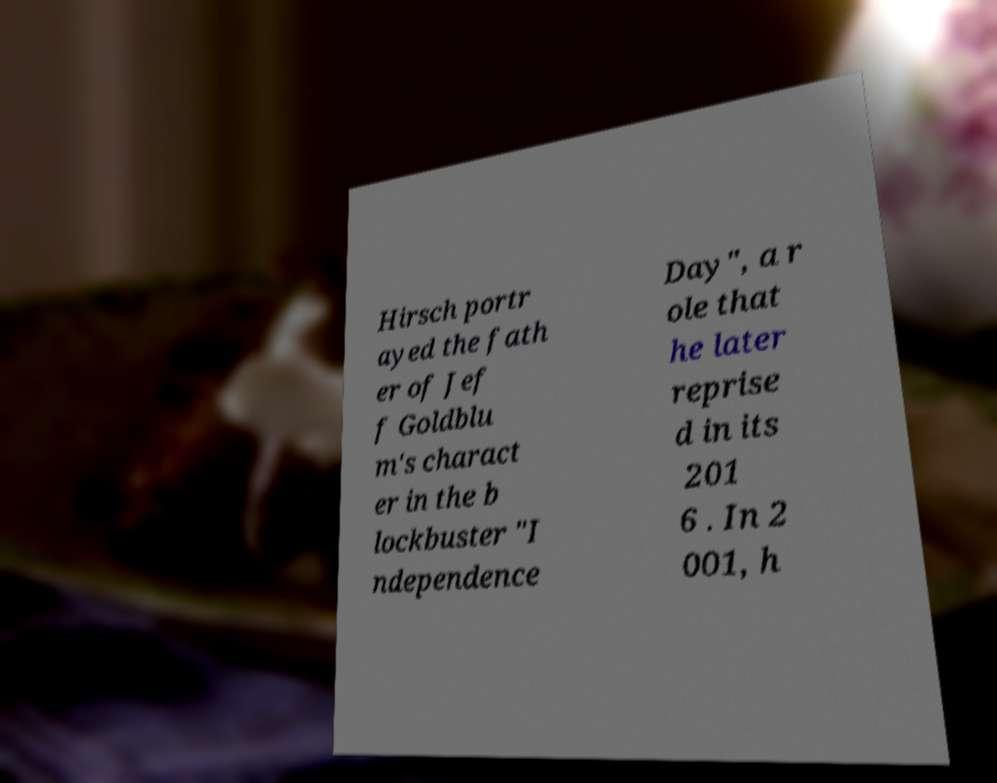What messages or text are displayed in this image? I need them in a readable, typed format. Hirsch portr ayed the fath er of Jef f Goldblu m's charact er in the b lockbuster "I ndependence Day", a r ole that he later reprise d in its 201 6 . In 2 001, h 